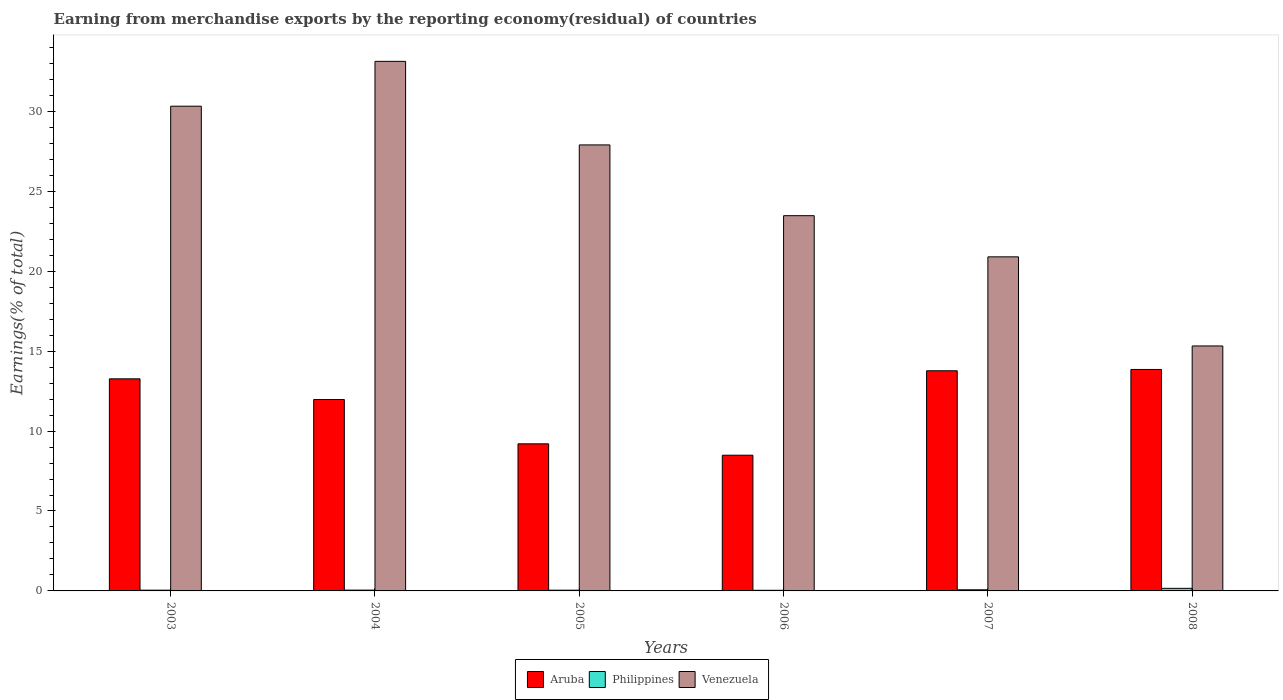How many different coloured bars are there?
Offer a very short reply. 3. Are the number of bars per tick equal to the number of legend labels?
Provide a succinct answer. Yes. Are the number of bars on each tick of the X-axis equal?
Offer a very short reply. Yes. How many bars are there on the 1st tick from the left?
Provide a succinct answer. 3. How many bars are there on the 4th tick from the right?
Ensure brevity in your answer.  3. In how many cases, is the number of bars for a given year not equal to the number of legend labels?
Your answer should be very brief. 0. What is the percentage of amount earned from merchandise exports in Philippines in 2005?
Offer a very short reply. 0.05. Across all years, what is the maximum percentage of amount earned from merchandise exports in Aruba?
Ensure brevity in your answer.  13.85. Across all years, what is the minimum percentage of amount earned from merchandise exports in Aruba?
Provide a short and direct response. 8.49. What is the total percentage of amount earned from merchandise exports in Aruba in the graph?
Provide a succinct answer. 70.56. What is the difference between the percentage of amount earned from merchandise exports in Venezuela in 2003 and that in 2004?
Your answer should be compact. -2.81. What is the difference between the percentage of amount earned from merchandise exports in Philippines in 2003 and the percentage of amount earned from merchandise exports in Aruba in 2004?
Your answer should be compact. -11.93. What is the average percentage of amount earned from merchandise exports in Aruba per year?
Offer a very short reply. 11.76. In the year 2005, what is the difference between the percentage of amount earned from merchandise exports in Venezuela and percentage of amount earned from merchandise exports in Philippines?
Provide a short and direct response. 27.86. What is the ratio of the percentage of amount earned from merchandise exports in Venezuela in 2004 to that in 2005?
Offer a terse response. 1.19. Is the percentage of amount earned from merchandise exports in Philippines in 2003 less than that in 2005?
Your answer should be compact. No. Is the difference between the percentage of amount earned from merchandise exports in Venezuela in 2003 and 2006 greater than the difference between the percentage of amount earned from merchandise exports in Philippines in 2003 and 2006?
Your answer should be compact. Yes. What is the difference between the highest and the second highest percentage of amount earned from merchandise exports in Philippines?
Offer a terse response. 0.09. What is the difference between the highest and the lowest percentage of amount earned from merchandise exports in Philippines?
Ensure brevity in your answer.  0.12. Is the sum of the percentage of amount earned from merchandise exports in Philippines in 2004 and 2008 greater than the maximum percentage of amount earned from merchandise exports in Aruba across all years?
Offer a very short reply. No. What does the 1st bar from the right in 2003 represents?
Offer a very short reply. Venezuela. Is it the case that in every year, the sum of the percentage of amount earned from merchandise exports in Philippines and percentage of amount earned from merchandise exports in Venezuela is greater than the percentage of amount earned from merchandise exports in Aruba?
Provide a short and direct response. Yes. Are the values on the major ticks of Y-axis written in scientific E-notation?
Your answer should be very brief. No. Does the graph contain any zero values?
Provide a succinct answer. No. Does the graph contain grids?
Your answer should be very brief. No. Where does the legend appear in the graph?
Give a very brief answer. Bottom center. How are the legend labels stacked?
Your response must be concise. Horizontal. What is the title of the graph?
Your answer should be very brief. Earning from merchandise exports by the reporting economy(residual) of countries. Does "Mali" appear as one of the legend labels in the graph?
Ensure brevity in your answer.  No. What is the label or title of the Y-axis?
Keep it short and to the point. Earnings(% of total). What is the Earnings(% of total) in Aruba in 2003?
Your answer should be very brief. 13.27. What is the Earnings(% of total) of Philippines in 2003?
Offer a terse response. 0.05. What is the Earnings(% of total) in Venezuela in 2003?
Your answer should be very brief. 30.32. What is the Earnings(% of total) in Aruba in 2004?
Offer a very short reply. 11.97. What is the Earnings(% of total) of Philippines in 2004?
Offer a terse response. 0.05. What is the Earnings(% of total) of Venezuela in 2004?
Your answer should be compact. 33.13. What is the Earnings(% of total) in Aruba in 2005?
Your answer should be very brief. 9.2. What is the Earnings(% of total) of Philippines in 2005?
Your response must be concise. 0.05. What is the Earnings(% of total) in Venezuela in 2005?
Give a very brief answer. 27.9. What is the Earnings(% of total) in Aruba in 2006?
Make the answer very short. 8.49. What is the Earnings(% of total) of Philippines in 2006?
Provide a succinct answer. 0.04. What is the Earnings(% of total) in Venezuela in 2006?
Offer a very short reply. 23.48. What is the Earnings(% of total) in Aruba in 2007?
Offer a very short reply. 13.77. What is the Earnings(% of total) of Philippines in 2007?
Your response must be concise. 0.07. What is the Earnings(% of total) in Venezuela in 2007?
Make the answer very short. 20.9. What is the Earnings(% of total) of Aruba in 2008?
Offer a very short reply. 13.85. What is the Earnings(% of total) in Philippines in 2008?
Provide a short and direct response. 0.16. What is the Earnings(% of total) of Venezuela in 2008?
Provide a succinct answer. 15.32. Across all years, what is the maximum Earnings(% of total) of Aruba?
Your answer should be compact. 13.85. Across all years, what is the maximum Earnings(% of total) of Philippines?
Provide a succinct answer. 0.16. Across all years, what is the maximum Earnings(% of total) in Venezuela?
Your response must be concise. 33.13. Across all years, what is the minimum Earnings(% of total) in Aruba?
Offer a terse response. 8.49. Across all years, what is the minimum Earnings(% of total) of Philippines?
Ensure brevity in your answer.  0.04. Across all years, what is the minimum Earnings(% of total) in Venezuela?
Keep it short and to the point. 15.32. What is the total Earnings(% of total) in Aruba in the graph?
Keep it short and to the point. 70.56. What is the total Earnings(% of total) of Philippines in the graph?
Your answer should be compact. 0.41. What is the total Earnings(% of total) of Venezuela in the graph?
Give a very brief answer. 151.05. What is the difference between the Earnings(% of total) in Aruba in 2003 and that in 2004?
Your answer should be compact. 1.29. What is the difference between the Earnings(% of total) in Philippines in 2003 and that in 2004?
Provide a succinct answer. -0. What is the difference between the Earnings(% of total) of Venezuela in 2003 and that in 2004?
Give a very brief answer. -2.81. What is the difference between the Earnings(% of total) of Aruba in 2003 and that in 2005?
Your answer should be very brief. 4.07. What is the difference between the Earnings(% of total) of Philippines in 2003 and that in 2005?
Give a very brief answer. 0. What is the difference between the Earnings(% of total) in Venezuela in 2003 and that in 2005?
Your answer should be very brief. 2.42. What is the difference between the Earnings(% of total) in Aruba in 2003 and that in 2006?
Ensure brevity in your answer.  4.78. What is the difference between the Earnings(% of total) in Philippines in 2003 and that in 2006?
Make the answer very short. 0.01. What is the difference between the Earnings(% of total) of Venezuela in 2003 and that in 2006?
Your answer should be compact. 6.85. What is the difference between the Earnings(% of total) of Aruba in 2003 and that in 2007?
Make the answer very short. -0.5. What is the difference between the Earnings(% of total) in Philippines in 2003 and that in 2007?
Your answer should be compact. -0.02. What is the difference between the Earnings(% of total) of Venezuela in 2003 and that in 2007?
Provide a succinct answer. 9.43. What is the difference between the Earnings(% of total) in Aruba in 2003 and that in 2008?
Provide a succinct answer. -0.59. What is the difference between the Earnings(% of total) in Philippines in 2003 and that in 2008?
Give a very brief answer. -0.12. What is the difference between the Earnings(% of total) of Venezuela in 2003 and that in 2008?
Give a very brief answer. 15. What is the difference between the Earnings(% of total) in Aruba in 2004 and that in 2005?
Keep it short and to the point. 2.77. What is the difference between the Earnings(% of total) in Philippines in 2004 and that in 2005?
Provide a succinct answer. 0.01. What is the difference between the Earnings(% of total) of Venezuela in 2004 and that in 2005?
Ensure brevity in your answer.  5.23. What is the difference between the Earnings(% of total) in Aruba in 2004 and that in 2006?
Provide a succinct answer. 3.48. What is the difference between the Earnings(% of total) in Philippines in 2004 and that in 2006?
Keep it short and to the point. 0.01. What is the difference between the Earnings(% of total) of Venezuela in 2004 and that in 2006?
Offer a very short reply. 9.65. What is the difference between the Earnings(% of total) in Aruba in 2004 and that in 2007?
Your response must be concise. -1.8. What is the difference between the Earnings(% of total) of Philippines in 2004 and that in 2007?
Offer a terse response. -0.02. What is the difference between the Earnings(% of total) in Venezuela in 2004 and that in 2007?
Your answer should be compact. 12.23. What is the difference between the Earnings(% of total) in Aruba in 2004 and that in 2008?
Make the answer very short. -1.88. What is the difference between the Earnings(% of total) of Philippines in 2004 and that in 2008?
Your answer should be very brief. -0.11. What is the difference between the Earnings(% of total) of Venezuela in 2004 and that in 2008?
Your answer should be compact. 17.81. What is the difference between the Earnings(% of total) of Aruba in 2005 and that in 2006?
Make the answer very short. 0.71. What is the difference between the Earnings(% of total) in Philippines in 2005 and that in 2006?
Ensure brevity in your answer.  0.01. What is the difference between the Earnings(% of total) in Venezuela in 2005 and that in 2006?
Provide a short and direct response. 4.43. What is the difference between the Earnings(% of total) in Aruba in 2005 and that in 2007?
Provide a short and direct response. -4.57. What is the difference between the Earnings(% of total) in Philippines in 2005 and that in 2007?
Your response must be concise. -0.03. What is the difference between the Earnings(% of total) in Venezuela in 2005 and that in 2007?
Make the answer very short. 7. What is the difference between the Earnings(% of total) in Aruba in 2005 and that in 2008?
Keep it short and to the point. -4.65. What is the difference between the Earnings(% of total) in Philippines in 2005 and that in 2008?
Offer a very short reply. -0.12. What is the difference between the Earnings(% of total) in Venezuela in 2005 and that in 2008?
Keep it short and to the point. 12.58. What is the difference between the Earnings(% of total) in Aruba in 2006 and that in 2007?
Your response must be concise. -5.28. What is the difference between the Earnings(% of total) of Philippines in 2006 and that in 2007?
Your answer should be very brief. -0.03. What is the difference between the Earnings(% of total) in Venezuela in 2006 and that in 2007?
Your answer should be compact. 2.58. What is the difference between the Earnings(% of total) in Aruba in 2006 and that in 2008?
Provide a succinct answer. -5.36. What is the difference between the Earnings(% of total) in Philippines in 2006 and that in 2008?
Your answer should be very brief. -0.12. What is the difference between the Earnings(% of total) in Venezuela in 2006 and that in 2008?
Offer a terse response. 8.15. What is the difference between the Earnings(% of total) of Aruba in 2007 and that in 2008?
Give a very brief answer. -0.08. What is the difference between the Earnings(% of total) in Philippines in 2007 and that in 2008?
Ensure brevity in your answer.  -0.09. What is the difference between the Earnings(% of total) of Venezuela in 2007 and that in 2008?
Your answer should be compact. 5.57. What is the difference between the Earnings(% of total) of Aruba in 2003 and the Earnings(% of total) of Philippines in 2004?
Offer a very short reply. 13.22. What is the difference between the Earnings(% of total) in Aruba in 2003 and the Earnings(% of total) in Venezuela in 2004?
Offer a very short reply. -19.86. What is the difference between the Earnings(% of total) in Philippines in 2003 and the Earnings(% of total) in Venezuela in 2004?
Ensure brevity in your answer.  -33.08. What is the difference between the Earnings(% of total) in Aruba in 2003 and the Earnings(% of total) in Philippines in 2005?
Keep it short and to the point. 13.22. What is the difference between the Earnings(% of total) of Aruba in 2003 and the Earnings(% of total) of Venezuela in 2005?
Make the answer very short. -14.63. What is the difference between the Earnings(% of total) of Philippines in 2003 and the Earnings(% of total) of Venezuela in 2005?
Give a very brief answer. -27.86. What is the difference between the Earnings(% of total) of Aruba in 2003 and the Earnings(% of total) of Philippines in 2006?
Your answer should be compact. 13.23. What is the difference between the Earnings(% of total) in Aruba in 2003 and the Earnings(% of total) in Venezuela in 2006?
Make the answer very short. -10.21. What is the difference between the Earnings(% of total) in Philippines in 2003 and the Earnings(% of total) in Venezuela in 2006?
Your answer should be compact. -23.43. What is the difference between the Earnings(% of total) of Aruba in 2003 and the Earnings(% of total) of Philippines in 2007?
Your answer should be compact. 13.2. What is the difference between the Earnings(% of total) of Aruba in 2003 and the Earnings(% of total) of Venezuela in 2007?
Offer a terse response. -7.63. What is the difference between the Earnings(% of total) in Philippines in 2003 and the Earnings(% of total) in Venezuela in 2007?
Your response must be concise. -20.85. What is the difference between the Earnings(% of total) of Aruba in 2003 and the Earnings(% of total) of Philippines in 2008?
Give a very brief answer. 13.11. What is the difference between the Earnings(% of total) in Aruba in 2003 and the Earnings(% of total) in Venezuela in 2008?
Offer a very short reply. -2.06. What is the difference between the Earnings(% of total) in Philippines in 2003 and the Earnings(% of total) in Venezuela in 2008?
Give a very brief answer. -15.28. What is the difference between the Earnings(% of total) of Aruba in 2004 and the Earnings(% of total) of Philippines in 2005?
Keep it short and to the point. 11.93. What is the difference between the Earnings(% of total) in Aruba in 2004 and the Earnings(% of total) in Venezuela in 2005?
Provide a succinct answer. -15.93. What is the difference between the Earnings(% of total) in Philippines in 2004 and the Earnings(% of total) in Venezuela in 2005?
Keep it short and to the point. -27.85. What is the difference between the Earnings(% of total) in Aruba in 2004 and the Earnings(% of total) in Philippines in 2006?
Your answer should be very brief. 11.94. What is the difference between the Earnings(% of total) of Aruba in 2004 and the Earnings(% of total) of Venezuela in 2006?
Make the answer very short. -11.5. What is the difference between the Earnings(% of total) of Philippines in 2004 and the Earnings(% of total) of Venezuela in 2006?
Ensure brevity in your answer.  -23.42. What is the difference between the Earnings(% of total) of Aruba in 2004 and the Earnings(% of total) of Philippines in 2007?
Keep it short and to the point. 11.9. What is the difference between the Earnings(% of total) in Aruba in 2004 and the Earnings(% of total) in Venezuela in 2007?
Offer a very short reply. -8.92. What is the difference between the Earnings(% of total) of Philippines in 2004 and the Earnings(% of total) of Venezuela in 2007?
Ensure brevity in your answer.  -20.85. What is the difference between the Earnings(% of total) in Aruba in 2004 and the Earnings(% of total) in Philippines in 2008?
Offer a terse response. 11.81. What is the difference between the Earnings(% of total) of Aruba in 2004 and the Earnings(% of total) of Venezuela in 2008?
Your answer should be very brief. -3.35. What is the difference between the Earnings(% of total) in Philippines in 2004 and the Earnings(% of total) in Venezuela in 2008?
Your response must be concise. -15.27. What is the difference between the Earnings(% of total) of Aruba in 2005 and the Earnings(% of total) of Philippines in 2006?
Your answer should be very brief. 9.16. What is the difference between the Earnings(% of total) in Aruba in 2005 and the Earnings(% of total) in Venezuela in 2006?
Your answer should be very brief. -14.27. What is the difference between the Earnings(% of total) of Philippines in 2005 and the Earnings(% of total) of Venezuela in 2006?
Make the answer very short. -23.43. What is the difference between the Earnings(% of total) in Aruba in 2005 and the Earnings(% of total) in Philippines in 2007?
Provide a succinct answer. 9.13. What is the difference between the Earnings(% of total) of Aruba in 2005 and the Earnings(% of total) of Venezuela in 2007?
Give a very brief answer. -11.7. What is the difference between the Earnings(% of total) of Philippines in 2005 and the Earnings(% of total) of Venezuela in 2007?
Provide a short and direct response. -20.85. What is the difference between the Earnings(% of total) of Aruba in 2005 and the Earnings(% of total) of Philippines in 2008?
Keep it short and to the point. 9.04. What is the difference between the Earnings(% of total) of Aruba in 2005 and the Earnings(% of total) of Venezuela in 2008?
Offer a terse response. -6.12. What is the difference between the Earnings(% of total) in Philippines in 2005 and the Earnings(% of total) in Venezuela in 2008?
Provide a short and direct response. -15.28. What is the difference between the Earnings(% of total) in Aruba in 2006 and the Earnings(% of total) in Philippines in 2007?
Your answer should be very brief. 8.42. What is the difference between the Earnings(% of total) of Aruba in 2006 and the Earnings(% of total) of Venezuela in 2007?
Your answer should be very brief. -12.41. What is the difference between the Earnings(% of total) of Philippines in 2006 and the Earnings(% of total) of Venezuela in 2007?
Your response must be concise. -20.86. What is the difference between the Earnings(% of total) in Aruba in 2006 and the Earnings(% of total) in Philippines in 2008?
Your answer should be very brief. 8.33. What is the difference between the Earnings(% of total) of Aruba in 2006 and the Earnings(% of total) of Venezuela in 2008?
Your response must be concise. -6.83. What is the difference between the Earnings(% of total) of Philippines in 2006 and the Earnings(% of total) of Venezuela in 2008?
Your response must be concise. -15.29. What is the difference between the Earnings(% of total) in Aruba in 2007 and the Earnings(% of total) in Philippines in 2008?
Offer a very short reply. 13.61. What is the difference between the Earnings(% of total) of Aruba in 2007 and the Earnings(% of total) of Venezuela in 2008?
Your answer should be very brief. -1.55. What is the difference between the Earnings(% of total) of Philippines in 2007 and the Earnings(% of total) of Venezuela in 2008?
Offer a very short reply. -15.25. What is the average Earnings(% of total) in Aruba per year?
Keep it short and to the point. 11.76. What is the average Earnings(% of total) in Philippines per year?
Keep it short and to the point. 0.07. What is the average Earnings(% of total) in Venezuela per year?
Provide a succinct answer. 25.18. In the year 2003, what is the difference between the Earnings(% of total) in Aruba and Earnings(% of total) in Philippines?
Ensure brevity in your answer.  13.22. In the year 2003, what is the difference between the Earnings(% of total) in Aruba and Earnings(% of total) in Venezuela?
Give a very brief answer. -17.06. In the year 2003, what is the difference between the Earnings(% of total) of Philippines and Earnings(% of total) of Venezuela?
Your answer should be very brief. -30.28. In the year 2004, what is the difference between the Earnings(% of total) in Aruba and Earnings(% of total) in Philippines?
Your answer should be compact. 11.92. In the year 2004, what is the difference between the Earnings(% of total) of Aruba and Earnings(% of total) of Venezuela?
Your answer should be compact. -21.16. In the year 2004, what is the difference between the Earnings(% of total) of Philippines and Earnings(% of total) of Venezuela?
Keep it short and to the point. -33.08. In the year 2005, what is the difference between the Earnings(% of total) of Aruba and Earnings(% of total) of Philippines?
Provide a succinct answer. 9.16. In the year 2005, what is the difference between the Earnings(% of total) in Aruba and Earnings(% of total) in Venezuela?
Provide a short and direct response. -18.7. In the year 2005, what is the difference between the Earnings(% of total) of Philippines and Earnings(% of total) of Venezuela?
Give a very brief answer. -27.86. In the year 2006, what is the difference between the Earnings(% of total) of Aruba and Earnings(% of total) of Philippines?
Provide a succinct answer. 8.45. In the year 2006, what is the difference between the Earnings(% of total) of Aruba and Earnings(% of total) of Venezuela?
Provide a short and direct response. -14.99. In the year 2006, what is the difference between the Earnings(% of total) of Philippines and Earnings(% of total) of Venezuela?
Keep it short and to the point. -23.44. In the year 2007, what is the difference between the Earnings(% of total) of Aruba and Earnings(% of total) of Philippines?
Offer a very short reply. 13.7. In the year 2007, what is the difference between the Earnings(% of total) in Aruba and Earnings(% of total) in Venezuela?
Provide a succinct answer. -7.13. In the year 2007, what is the difference between the Earnings(% of total) of Philippines and Earnings(% of total) of Venezuela?
Your answer should be very brief. -20.83. In the year 2008, what is the difference between the Earnings(% of total) in Aruba and Earnings(% of total) in Philippines?
Ensure brevity in your answer.  13.69. In the year 2008, what is the difference between the Earnings(% of total) of Aruba and Earnings(% of total) of Venezuela?
Your response must be concise. -1.47. In the year 2008, what is the difference between the Earnings(% of total) in Philippines and Earnings(% of total) in Venezuela?
Keep it short and to the point. -15.16. What is the ratio of the Earnings(% of total) of Aruba in 2003 to that in 2004?
Your answer should be very brief. 1.11. What is the ratio of the Earnings(% of total) in Philippines in 2003 to that in 2004?
Make the answer very short. 0.91. What is the ratio of the Earnings(% of total) of Venezuela in 2003 to that in 2004?
Your answer should be compact. 0.92. What is the ratio of the Earnings(% of total) in Aruba in 2003 to that in 2005?
Your answer should be very brief. 1.44. What is the ratio of the Earnings(% of total) in Philippines in 2003 to that in 2005?
Ensure brevity in your answer.  1.02. What is the ratio of the Earnings(% of total) of Venezuela in 2003 to that in 2005?
Provide a succinct answer. 1.09. What is the ratio of the Earnings(% of total) of Aruba in 2003 to that in 2006?
Your response must be concise. 1.56. What is the ratio of the Earnings(% of total) of Philippines in 2003 to that in 2006?
Offer a very short reply. 1.18. What is the ratio of the Earnings(% of total) of Venezuela in 2003 to that in 2006?
Your answer should be very brief. 1.29. What is the ratio of the Earnings(% of total) of Aruba in 2003 to that in 2007?
Provide a short and direct response. 0.96. What is the ratio of the Earnings(% of total) of Philippines in 2003 to that in 2007?
Your answer should be compact. 0.65. What is the ratio of the Earnings(% of total) in Venezuela in 2003 to that in 2007?
Make the answer very short. 1.45. What is the ratio of the Earnings(% of total) in Aruba in 2003 to that in 2008?
Offer a terse response. 0.96. What is the ratio of the Earnings(% of total) in Philippines in 2003 to that in 2008?
Your answer should be compact. 0.28. What is the ratio of the Earnings(% of total) of Venezuela in 2003 to that in 2008?
Provide a succinct answer. 1.98. What is the ratio of the Earnings(% of total) in Aruba in 2004 to that in 2005?
Your answer should be compact. 1.3. What is the ratio of the Earnings(% of total) in Philippines in 2004 to that in 2005?
Provide a short and direct response. 1.12. What is the ratio of the Earnings(% of total) of Venezuela in 2004 to that in 2005?
Provide a short and direct response. 1.19. What is the ratio of the Earnings(% of total) of Aruba in 2004 to that in 2006?
Offer a terse response. 1.41. What is the ratio of the Earnings(% of total) of Philippines in 2004 to that in 2006?
Your answer should be very brief. 1.3. What is the ratio of the Earnings(% of total) in Venezuela in 2004 to that in 2006?
Offer a very short reply. 1.41. What is the ratio of the Earnings(% of total) of Aruba in 2004 to that in 2007?
Provide a succinct answer. 0.87. What is the ratio of the Earnings(% of total) of Philippines in 2004 to that in 2007?
Offer a very short reply. 0.72. What is the ratio of the Earnings(% of total) of Venezuela in 2004 to that in 2007?
Keep it short and to the point. 1.59. What is the ratio of the Earnings(% of total) in Aruba in 2004 to that in 2008?
Make the answer very short. 0.86. What is the ratio of the Earnings(% of total) in Philippines in 2004 to that in 2008?
Your answer should be compact. 0.31. What is the ratio of the Earnings(% of total) in Venezuela in 2004 to that in 2008?
Your answer should be very brief. 2.16. What is the ratio of the Earnings(% of total) in Aruba in 2005 to that in 2006?
Ensure brevity in your answer.  1.08. What is the ratio of the Earnings(% of total) in Philippines in 2005 to that in 2006?
Give a very brief answer. 1.16. What is the ratio of the Earnings(% of total) of Venezuela in 2005 to that in 2006?
Ensure brevity in your answer.  1.19. What is the ratio of the Earnings(% of total) in Aruba in 2005 to that in 2007?
Your answer should be compact. 0.67. What is the ratio of the Earnings(% of total) in Philippines in 2005 to that in 2007?
Your answer should be very brief. 0.64. What is the ratio of the Earnings(% of total) in Venezuela in 2005 to that in 2007?
Make the answer very short. 1.34. What is the ratio of the Earnings(% of total) in Aruba in 2005 to that in 2008?
Provide a succinct answer. 0.66. What is the ratio of the Earnings(% of total) in Philippines in 2005 to that in 2008?
Provide a succinct answer. 0.28. What is the ratio of the Earnings(% of total) in Venezuela in 2005 to that in 2008?
Make the answer very short. 1.82. What is the ratio of the Earnings(% of total) in Aruba in 2006 to that in 2007?
Your answer should be very brief. 0.62. What is the ratio of the Earnings(% of total) in Philippines in 2006 to that in 2007?
Offer a terse response. 0.55. What is the ratio of the Earnings(% of total) of Venezuela in 2006 to that in 2007?
Make the answer very short. 1.12. What is the ratio of the Earnings(% of total) of Aruba in 2006 to that in 2008?
Your answer should be compact. 0.61. What is the ratio of the Earnings(% of total) in Philippines in 2006 to that in 2008?
Offer a very short reply. 0.24. What is the ratio of the Earnings(% of total) in Venezuela in 2006 to that in 2008?
Make the answer very short. 1.53. What is the ratio of the Earnings(% of total) of Philippines in 2007 to that in 2008?
Your answer should be compact. 0.44. What is the ratio of the Earnings(% of total) of Venezuela in 2007 to that in 2008?
Ensure brevity in your answer.  1.36. What is the difference between the highest and the second highest Earnings(% of total) of Aruba?
Offer a terse response. 0.08. What is the difference between the highest and the second highest Earnings(% of total) of Philippines?
Your response must be concise. 0.09. What is the difference between the highest and the second highest Earnings(% of total) of Venezuela?
Make the answer very short. 2.81. What is the difference between the highest and the lowest Earnings(% of total) of Aruba?
Keep it short and to the point. 5.36. What is the difference between the highest and the lowest Earnings(% of total) in Philippines?
Provide a short and direct response. 0.12. What is the difference between the highest and the lowest Earnings(% of total) in Venezuela?
Offer a terse response. 17.81. 